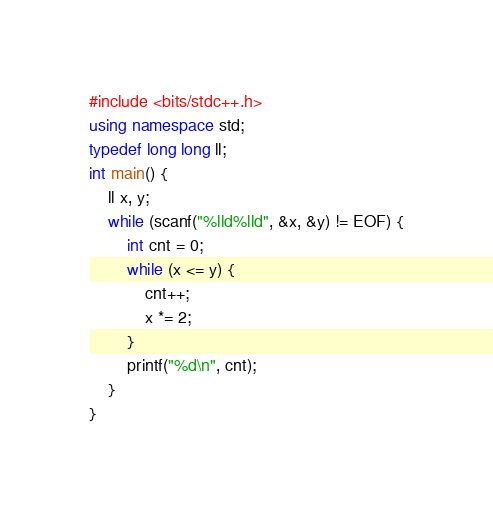Convert code to text. <code><loc_0><loc_0><loc_500><loc_500><_C++_>
#include <bits/stdc++.h>
using namespace std;
typedef long long ll;
int main() {
    ll x, y;
    while (scanf("%lld%lld", &x, &y) != EOF) {
        int cnt = 0;
        while (x <= y) {
            cnt++;
            x *= 2;
        }
        printf("%d\n", cnt);
    }
}</code> 